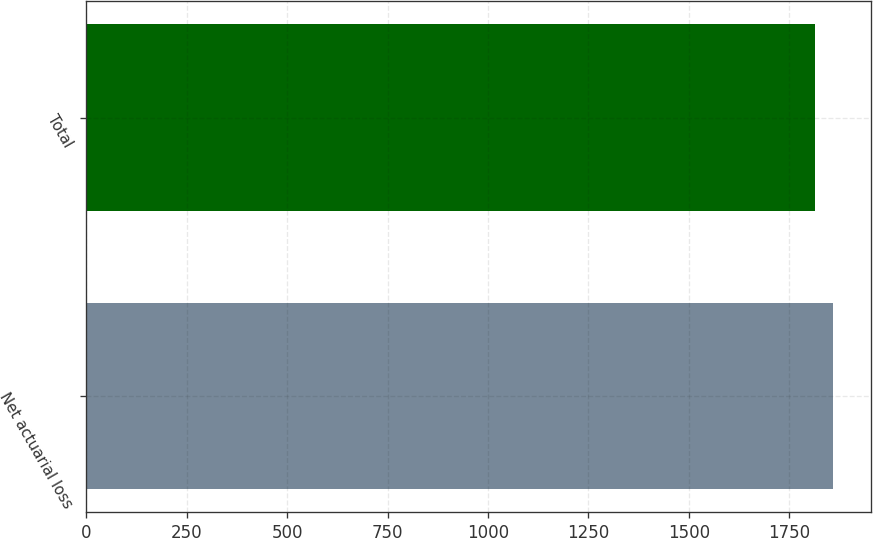Convert chart to OTSL. <chart><loc_0><loc_0><loc_500><loc_500><bar_chart><fcel>Net actuarial loss<fcel>Total<nl><fcel>1860<fcel>1815<nl></chart> 